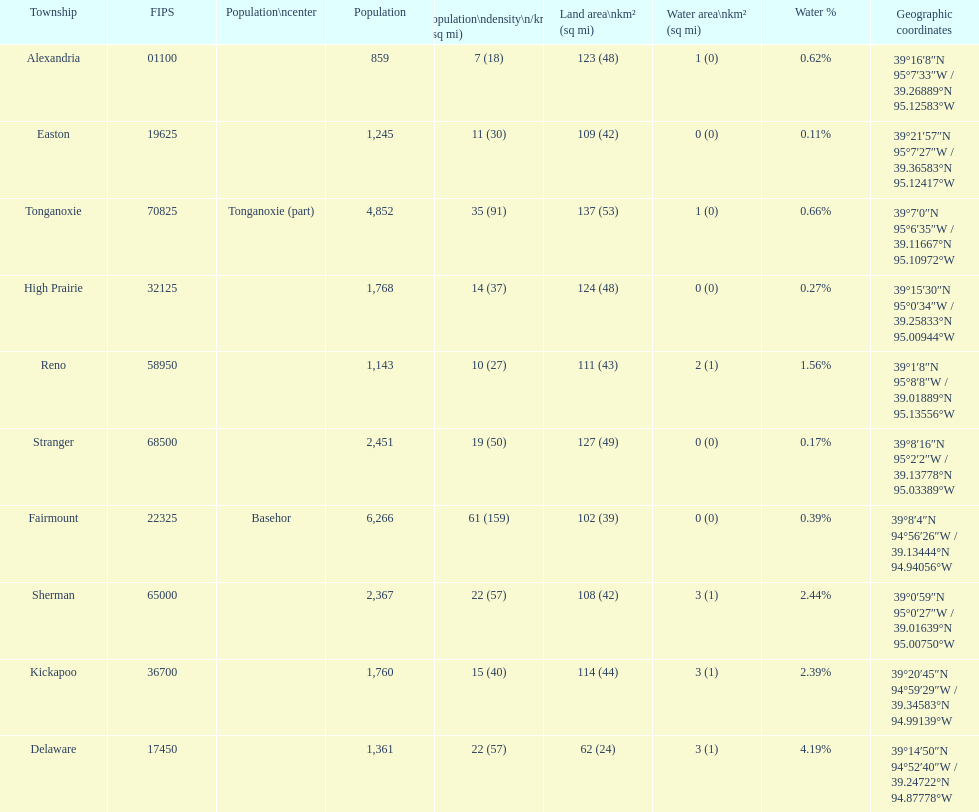Does alexandria county have a higher or lower population than delaware county? Lower. 